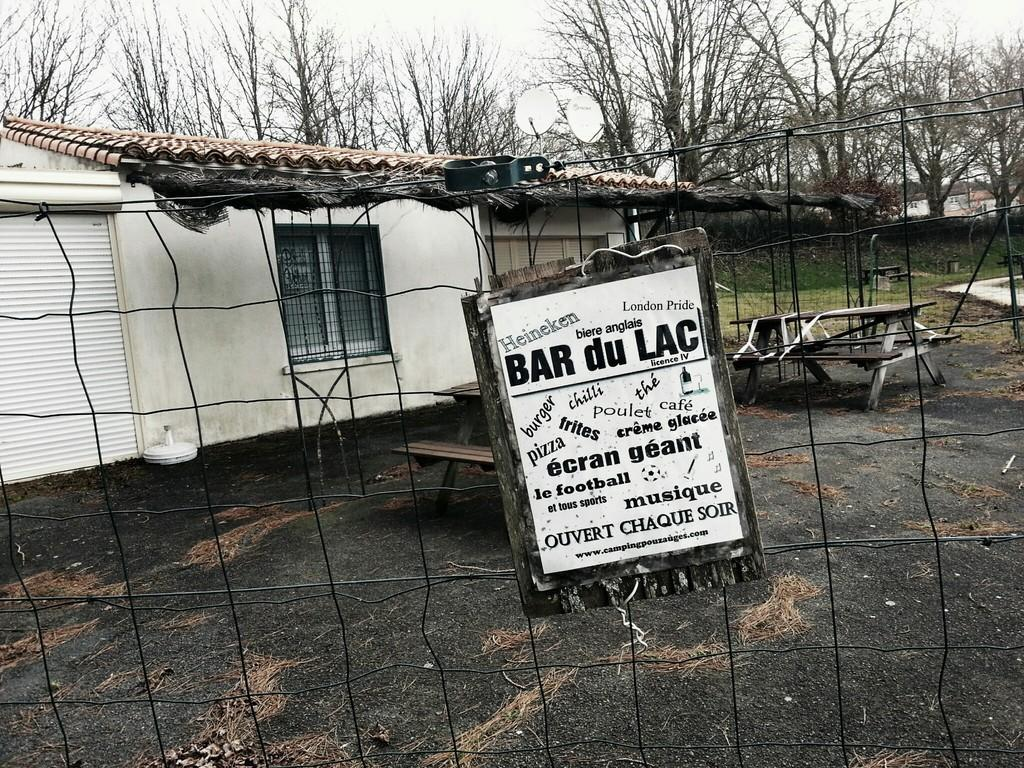<image>
Provide a brief description of the given image. A sign that says BAR du LAC on a fence in front of a building 